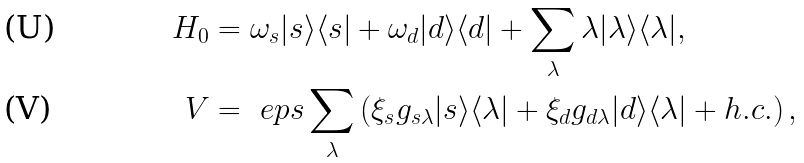Convert formula to latex. <formula><loc_0><loc_0><loc_500><loc_500>H _ { 0 } & = \omega _ { s } | s \rangle \langle s | + \omega _ { d } | d \rangle \langle d | + \sum _ { \lambda } \lambda | \lambda \rangle \langle \lambda | , \\ V & = \ e p s \sum _ { \lambda } \left ( \xi _ { s } g _ { s \lambda } | s \rangle \langle \lambda | + \xi _ { d } g _ { d \lambda } | d \rangle \langle \lambda | + h . c . \right ) ,</formula> 